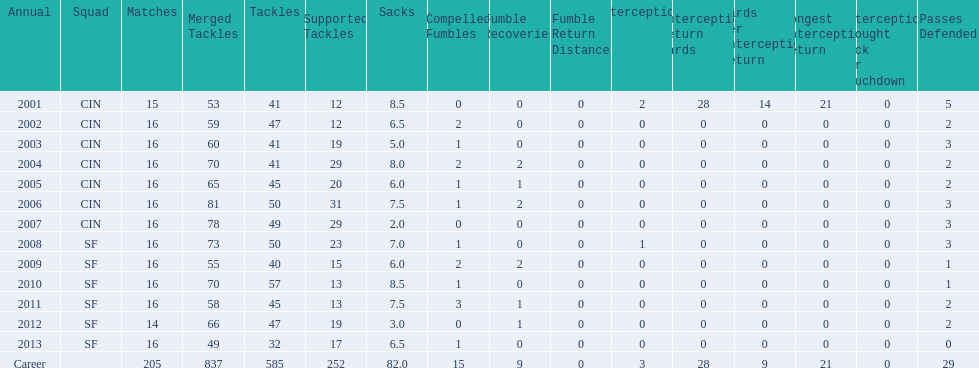What is the average number of tackles this player has had over his career? 45. 